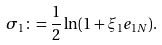Convert formula to latex. <formula><loc_0><loc_0><loc_500><loc_500>\sigma _ { 1 } \colon = \frac { 1 } { 2 } \ln ( 1 + \xi _ { 1 } e _ { 1 N } ) .</formula> 